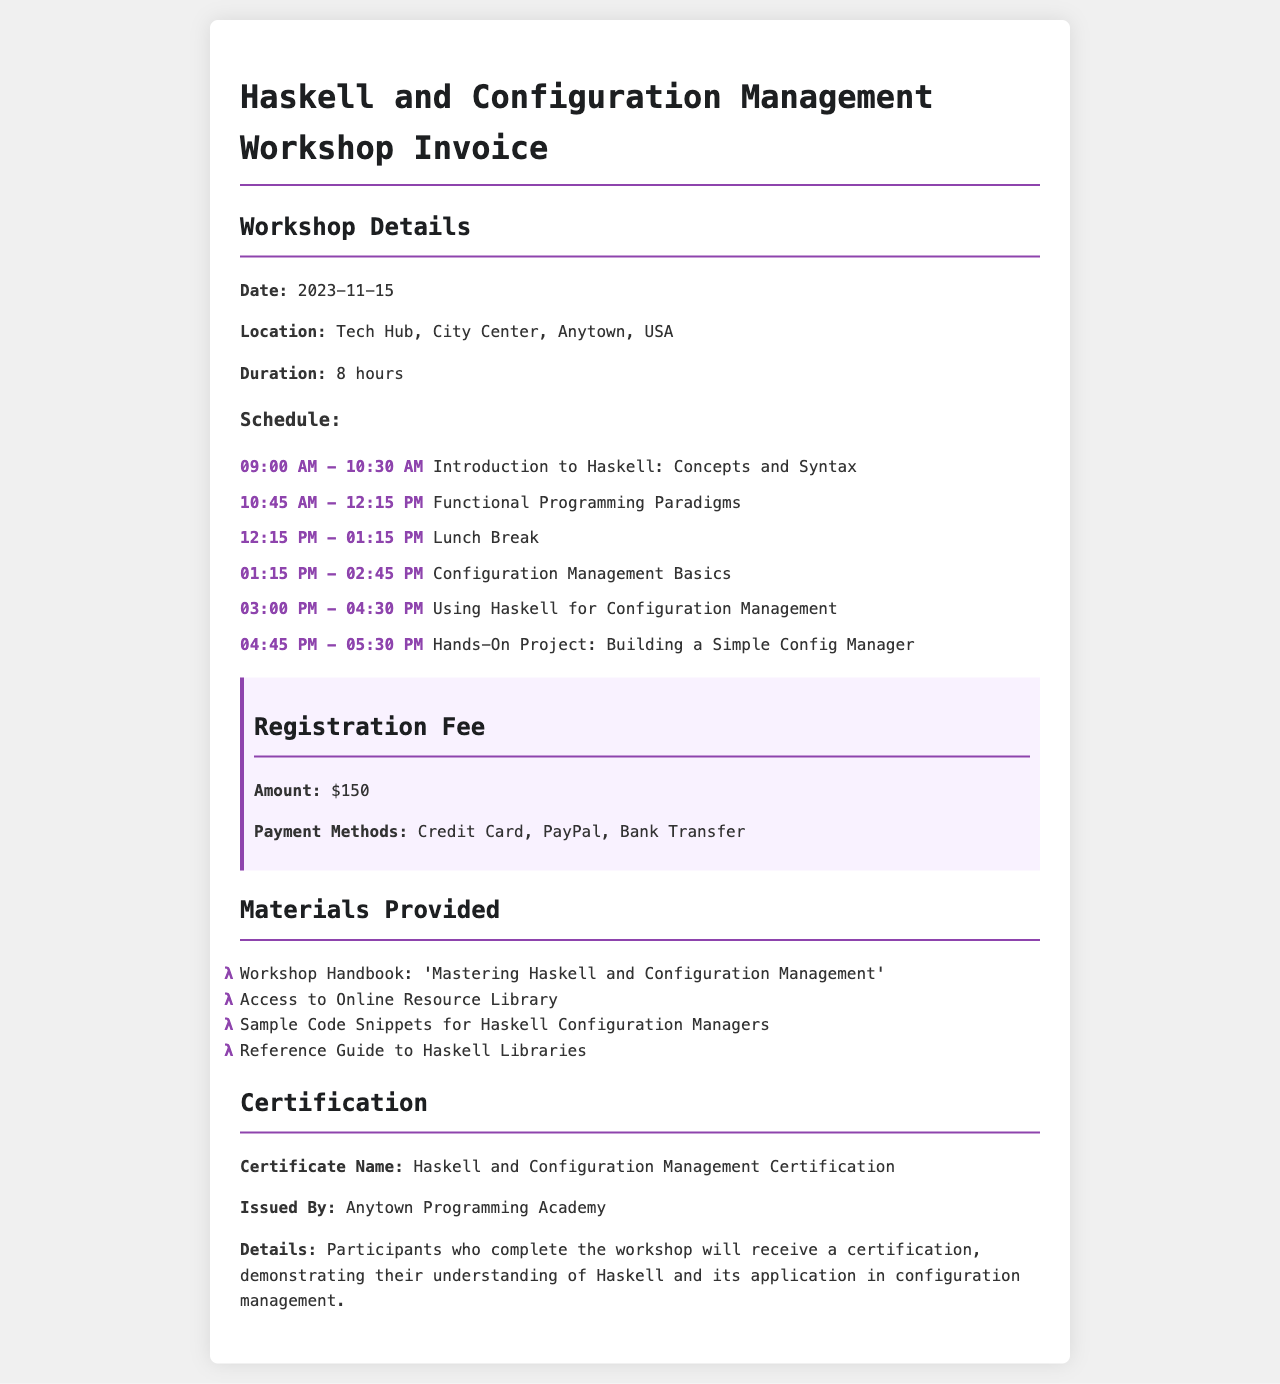What is the date of the workshop? The date of the workshop is clearly mentioned in the "Workshop Details" section of the document.
Answer: 2023-11-15 What is the location of the workshop? The location is specified in the "Workshop Details" section of the invoice.
Answer: Tech Hub, City Center, Anytown, USA What is the registration fee? The registration fee can be found in the "Registration Fee" section listed in the document.
Answer: $150 What materials are provided? The materials listed in the "Materials Provided" section give insight into the provided items.
Answer: Workshop Handbook, Access to Online Resource Library, Sample Code Snippets, Reference Guide to Haskell Libraries Who issues the certification? The entity responsible for issuing the certification is mentioned in the "Certification" section of the invoice.
Answer: Anytown Programming Academy What is the duration of the workshop? The duration of the workshop is specified in the "Workshop Details" section of the document.
Answer: 8 hours What is the schedule for the introduction to Haskell? The specific schedule for the introduction can be found in the "Schedule" subsection of the "Workshop Details" section.
Answer: 09:00 AM - 10:30 AM What is the name of the certification? The name of the certification is clearly indicated in the "Certification" section of the document.
Answer: Haskell and Configuration Management Certification 